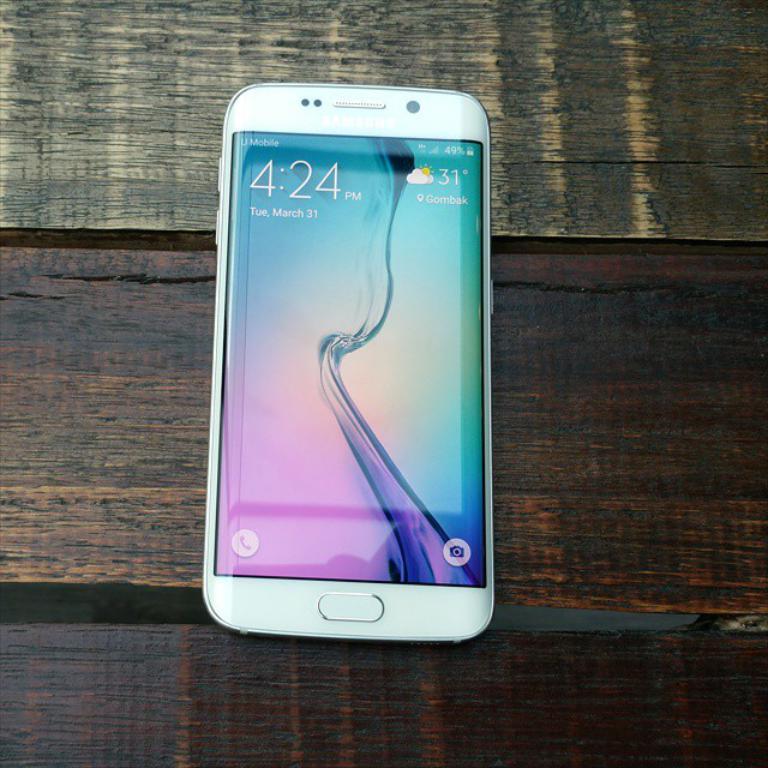What time is it?
Offer a very short reply. 4:24 pm. What is the date?
Your answer should be compact. March 31. 